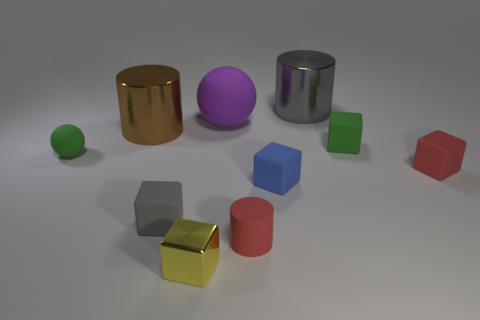Subtract all gray cylinders. How many cylinders are left? 2 Subtract 1 cubes. How many cubes are left? 4 Subtract all red cylinders. How many cylinders are left? 2 Subtract all cylinders. How many objects are left? 7 Subtract all blue spheres. Subtract all brown cubes. How many spheres are left? 2 Subtract all gray blocks. How many blue spheres are left? 0 Subtract all big brown metallic cylinders. Subtract all purple spheres. How many objects are left? 8 Add 8 tiny yellow metallic objects. How many tiny yellow metallic objects are left? 9 Add 10 big brown matte cylinders. How many big brown matte cylinders exist? 10 Subtract 1 brown cylinders. How many objects are left? 9 